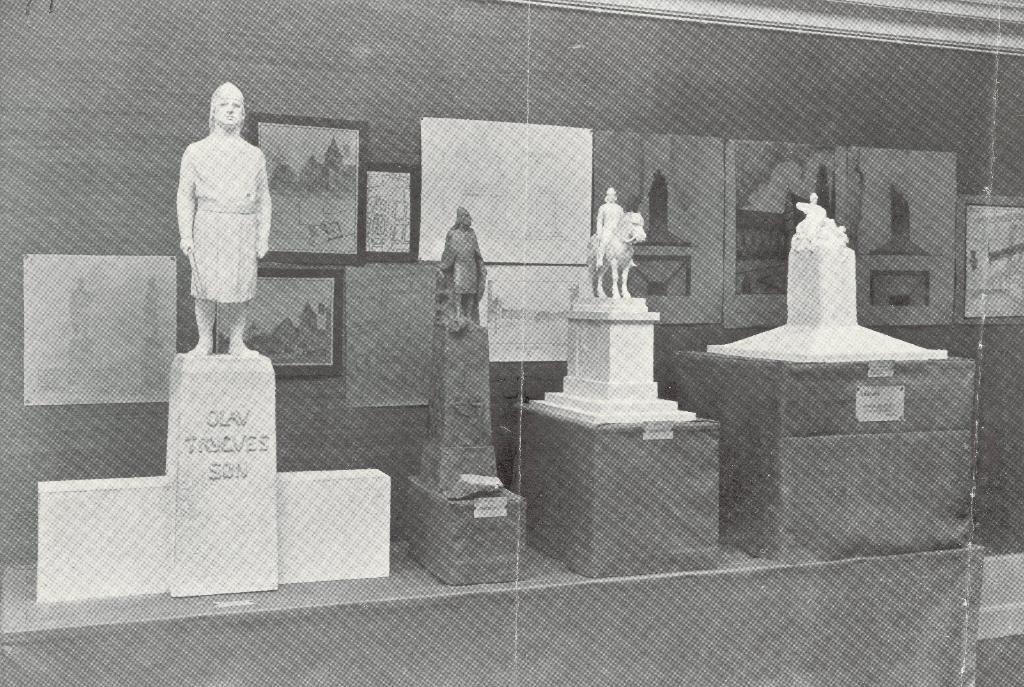Could you give a brief overview of what you see in this image? We can see sculptures on stones. In the background we can see frames and poster on a wall. 